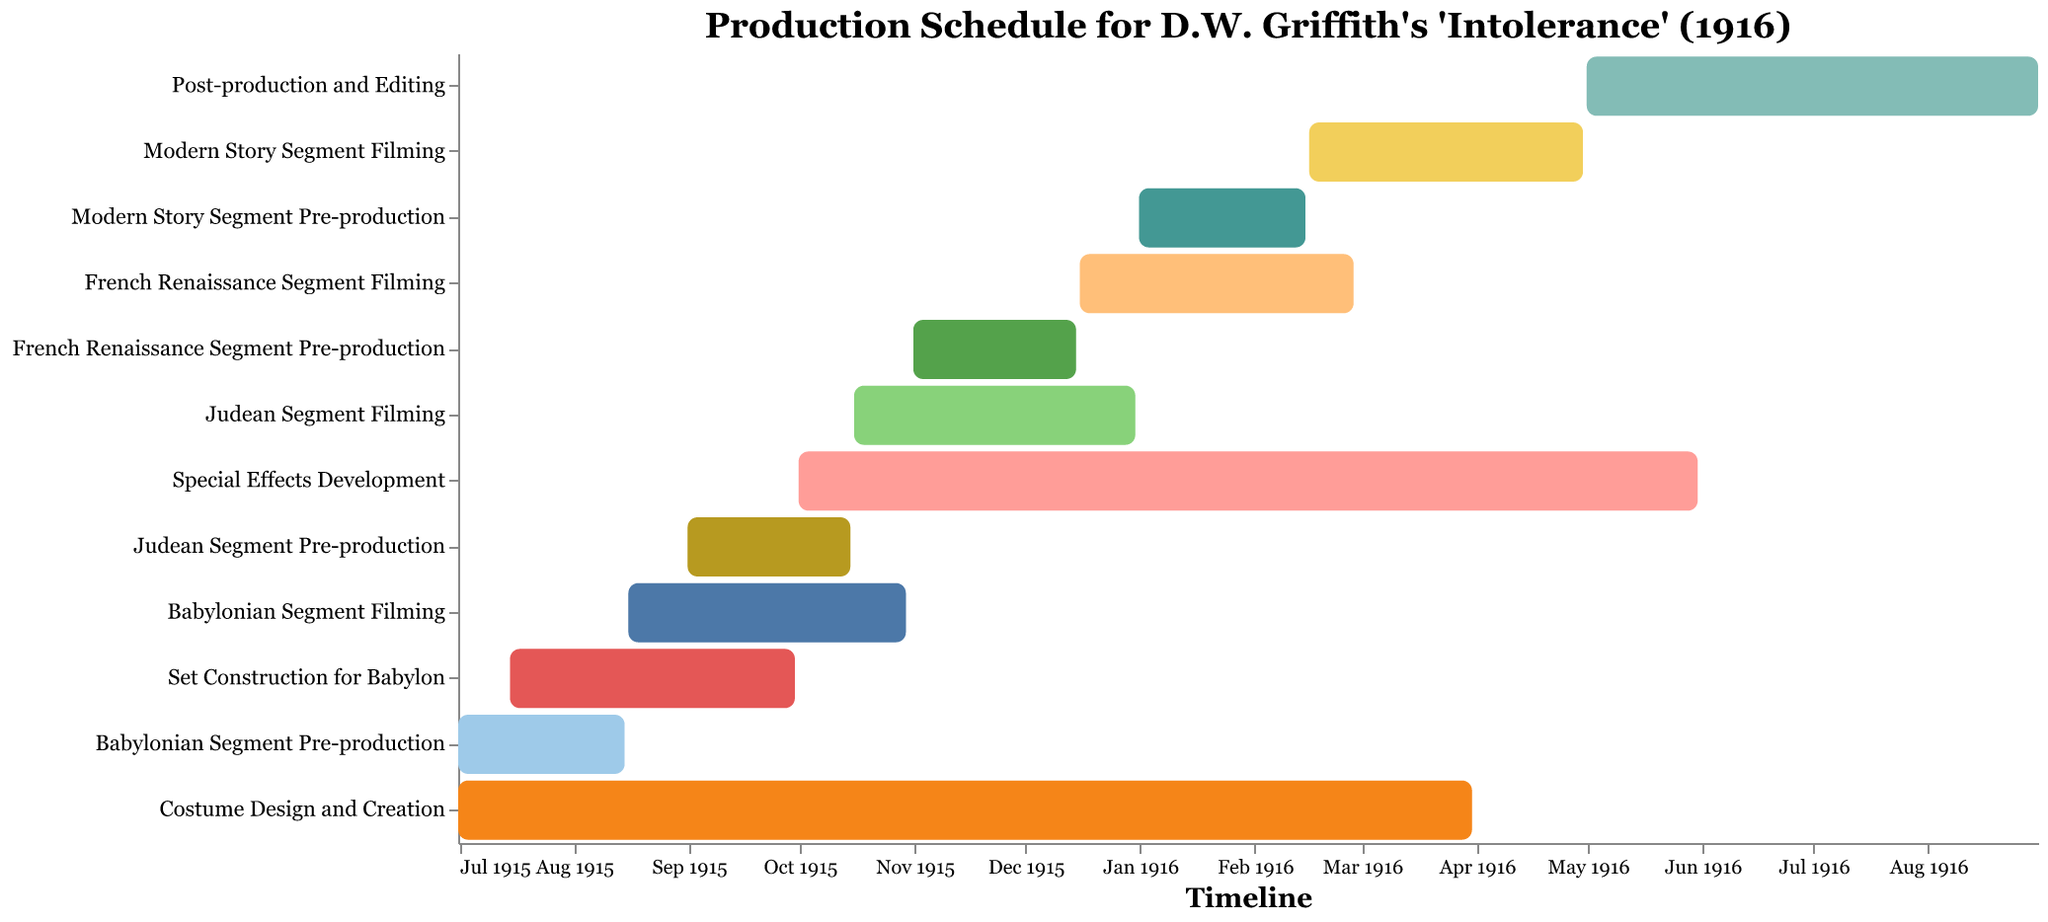What's the title of the figure? The title of the figure is usually prominently displayed at the top, and it is "Production Schedule for D.W. Griffith's 'Intolerance' (1916)".
Answer: Production Schedule for D.W. Griffith's 'Intolerance' (1916) When did the Special Effects Development start and end? By looking at the bar corresponding to Special Effects Development on the Gantt chart, we can see that it started on October 1, 1915, and ended on May 31, 1916.
Answer: October 1, 1915, to May 31, 1916 How long was the filming period for the French Renaissance Segment? The Gantt chart shows the start and end dates for each task. The French Renaissance Segment Filming started on December 16, 1915, and ended on February 28, 1916. This period lasts approximately 2.5 months.
Answer: Approximately 2.5 months Which task had the longest duration? Observing the Gantt chart, we can see that Costume Design and Creation spans from July 1, 1915, to March 31, 1916, making it the task with the longest duration.
Answer: Costume Design and Creation Were there any overlaps in the filming periods of different segments? If so, which ones? Reviewing the Gantt chart, we can see that there was an overlap between the Babylonian Segment Filming (August 16, 1915 - October 30, 1915) and the Judean Segment Filming (October 16, 1915 - December 31, 1915). There is also an overlap between the Judean Segment Filming and the French Renaissance Segment Filming (December 16, 1915 - February 28, 1916).
Answer: Babylonian and Judean segments, and Judean and French segments What is the time span for the entire production schedule shown in the figure? The overall production schedule starts with the Babylonian Segment Pre-production on July 1, 1915, and ends with the Post-production and Editing on August 31, 1916. Therefore, the total time span is from July 1915 to August 1916.
Answer: July 1915 to August 1916 How long was the Set Construction for Babylon in comparison to the Pre-production of the Babylonian Segment? The Set Construction for Babylon lasted from July 15, 1915, to September 30, 1915, while the Babylonian Segment Pre-production lasted from July 1, 1915, to August 15, 1915. The Set Construction therefore lasted longer (2.5 months versus 1.5 months).
Answer: Set Construction was longer by approximately 1 month Which segments' pre-production started first? By examining the chart, it's apparent that the Babylonian Segment Pre-production started first on July 1, 1915.
Answer: Babylonian Segment 